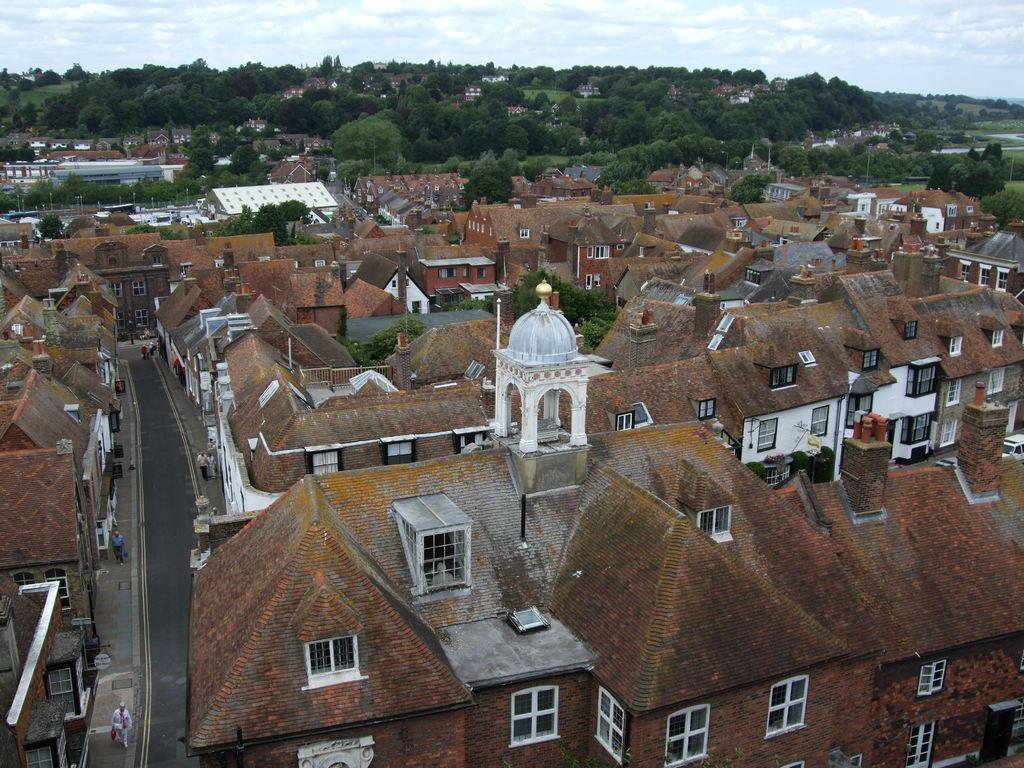What type of structures can be seen in the image? There are buildings in the image. What is the primary mode of transportation visible in the image? There is a road in the image. Are there any living beings present in the image? Yes, there are people in the image. What type of natural elements can be seen in the image? There are trees in the image. What is visible in the background of the image? The sky is visible in the image, and clouds are present in the sky. What is the price of the coast visible in the image? There is no coast present in the image, so it is not possible to determine its price. Why are the people in the image crying? There is no indication in the image that the people are crying, so it cannot be determined from the picture. 